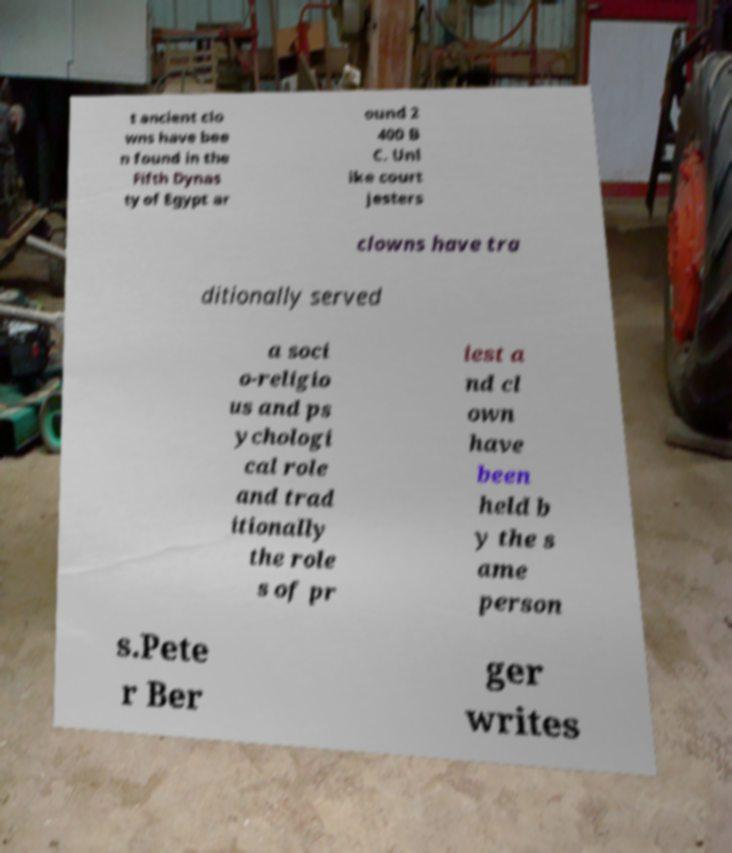For documentation purposes, I need the text within this image transcribed. Could you provide that? t ancient clo wns have bee n found in the Fifth Dynas ty of Egypt ar ound 2 400 B C. Unl ike court jesters clowns have tra ditionally served a soci o-religio us and ps ychologi cal role and trad itionally the role s of pr iest a nd cl own have been held b y the s ame person s.Pete r Ber ger writes 